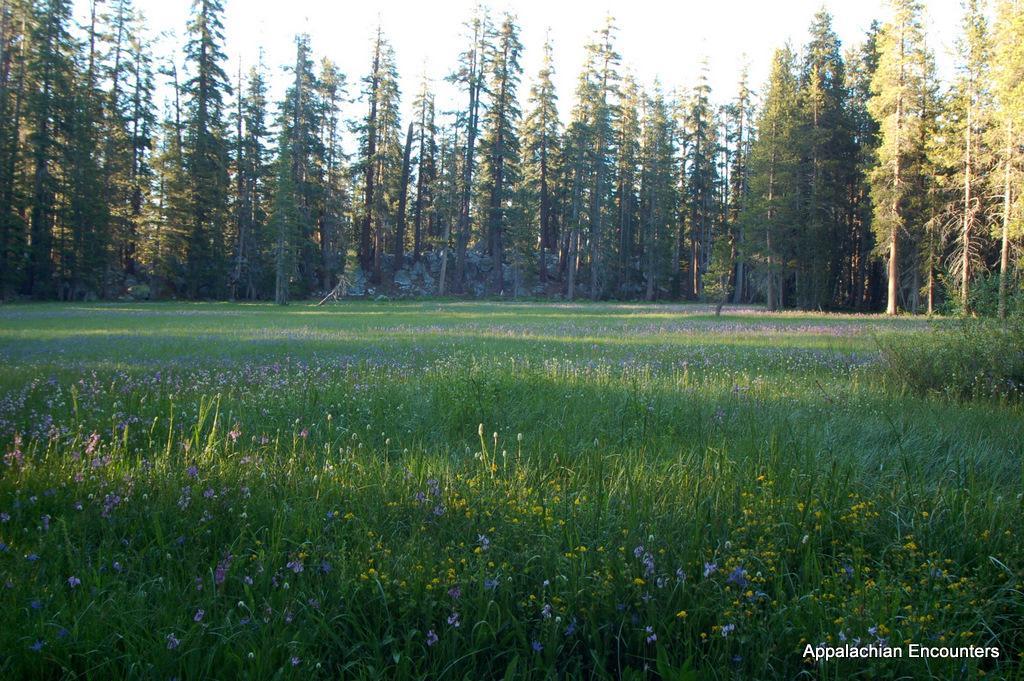In one or two sentences, can you explain what this image depicts? In the foreground we can see a field of plants and flowers. In the middle there are trees. At the top there is sky. 